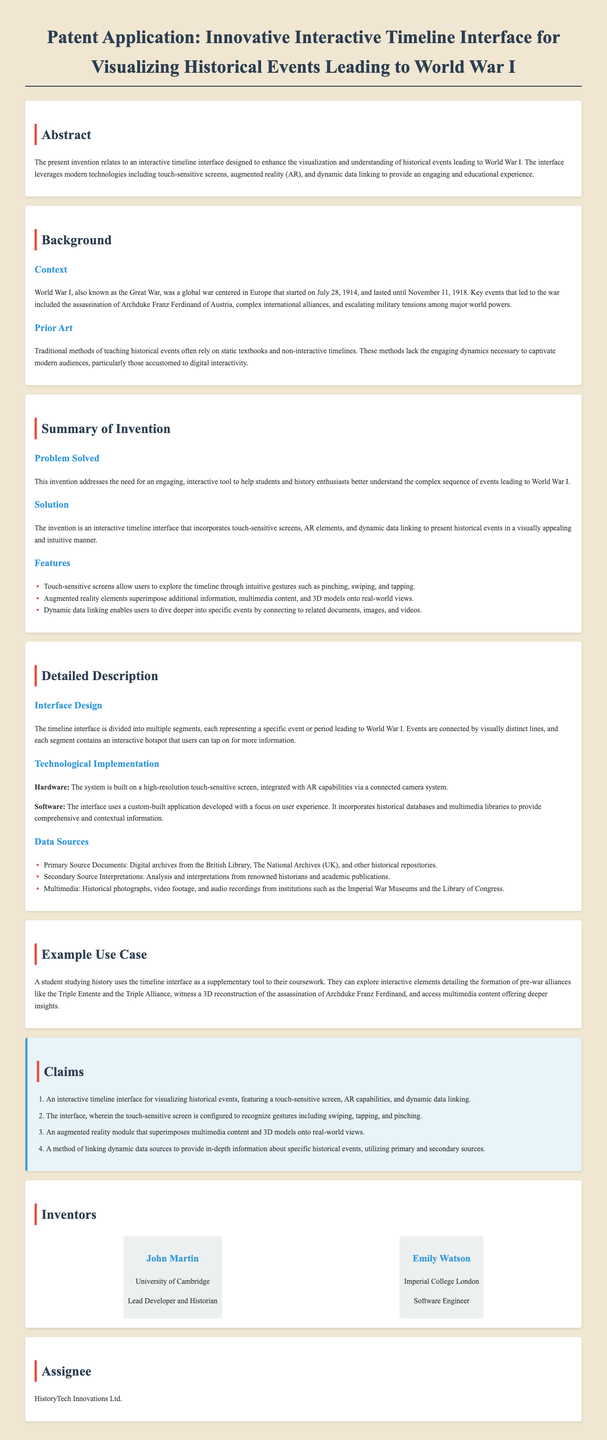What is the title of the patent application? The title is the main heading of the document, which introduces the subject of the invention.
Answer: Innovative Interactive Timeline Interface for Visualizing Historical Events Leading to World War I Who are the inventors listed in the application? The inventors are mentioned at the end of the document, along with their affiliations.
Answer: John Martin, Emily Watson What primary historical event is highlighted as a cause of World War I? This event is directly mentioned in the context of the background information related to the war's origins.
Answer: Assassination of Archduke Franz Ferdinand What feature enables users to explore the timeline interactively? This feature is specifically described in the summary of the invention, detailing how users interact with the timeline.
Answer: Touch-sensitive screens Which technology enhances the visualization of historical events in the interface? The document mentions a specific technology that is incorporated into the invention to improve the user experience.
Answer: Augmented reality How many claims are made in this patent application? The section titled "Claims" lists the specific claims made for the invention.
Answer: Four What organization is listed as the assignee in the patent application? The assignee is the entity to which the patent rights are assigned, mentioned towards the end of the document.
Answer: HistoryTech Innovations Ltd What type of content can be linked dynamically in the timeline interface? The document discusses the type of information that can be accessed through the timeline interface.
Answer: Historical events 